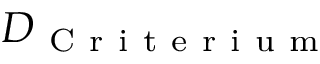<formula> <loc_0><loc_0><loc_500><loc_500>D _ { C r i t e r i u m }</formula> 